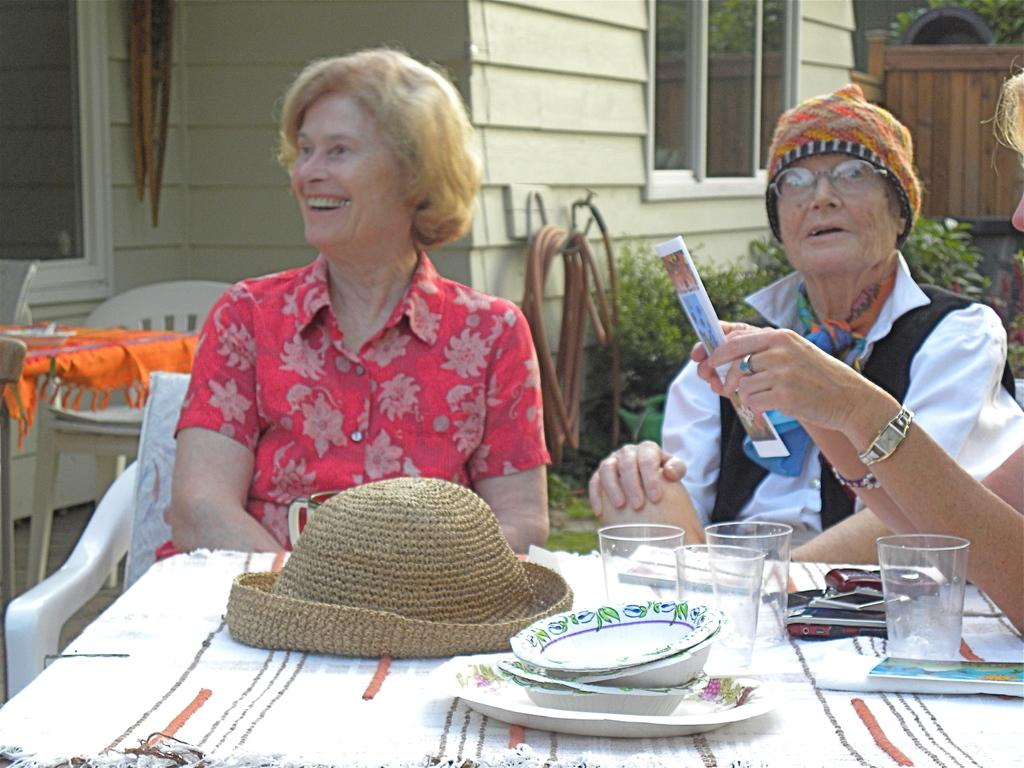How many women are present in the image? There are three women in the image. What are the women doing in the image? The women are seated on chairs. Can you describe any accessories in the image? Yes, there is a hat in the image. What items can be seen on the table? There are glasses and plates on the table. What can be seen in the background of the image? There is a house visible in the background of the image. What type of heart can be seen beating in the image? There is no heart visible in the image, beating or otherwise. Can you tell me how many basketballs are present in the image? There are no basketballs present in the image. 